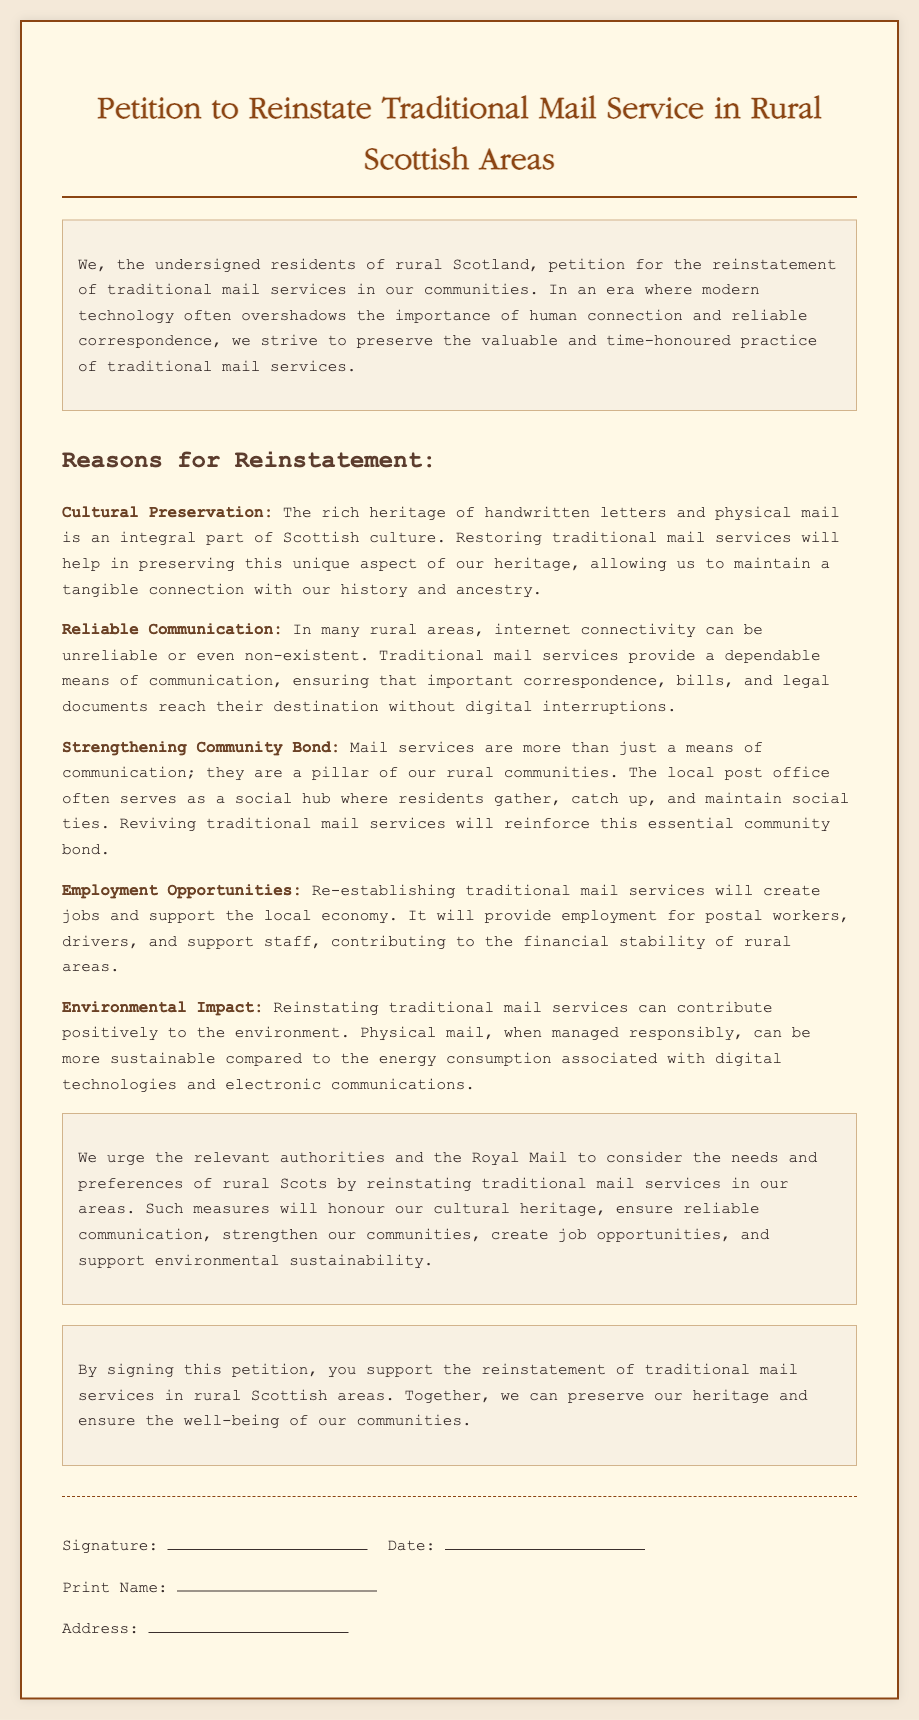What is the title of the petition? The title of the petition is clearly stated at the top of the document.
Answer: Petition to Reinstate Traditional Mail Service in Rural Scottish Areas Who are the petitioners? The petitioners are described as "the undersigned residents of rural Scotland" in the introduction.
Answer: residents of rural Scotland What is one reason for reinstating traditional mail services? Multiple reasons are listed in a bulleted format; one example will suffice for this question.
Answer: Cultural Preservation What type of employment will traditional mail services create? The document mentions specific roles that will be created if traditional mail services are reinstated.
Answer: jobs for postal workers What does the petition urge the authorities to consider? The petition describes specific needs that the authorities should consider regarding rural Scots.
Answer: reinstating traditional mail services What does the signature area contain? The signature area has specific lines for information which can be identified from the text.
Answer: Signature, Date, Print Name, Address How does reinstating mail services benefit the environment? The document states a specific environmental impact of reinstating mail services.
Answer: more sustainable What is the main call to action in the petition? The petition has a clear call to action summarized in one phrase near the end.
Answer: Consider the needs and preferences of rural Scots What is the purpose of the petition? The purpose is to advocate for a specific service in rural areas identified in the introduction section.
Answer: Reinstate traditional mail services 